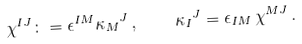<formula> <loc_0><loc_0><loc_500><loc_500>\chi ^ { I J } \colon = \epsilon ^ { I M } { \kappa _ { M } } ^ { J } \, , \quad { \kappa _ { I } } ^ { J } = \epsilon _ { I M } \, \chi ^ { M J } \, .</formula> 